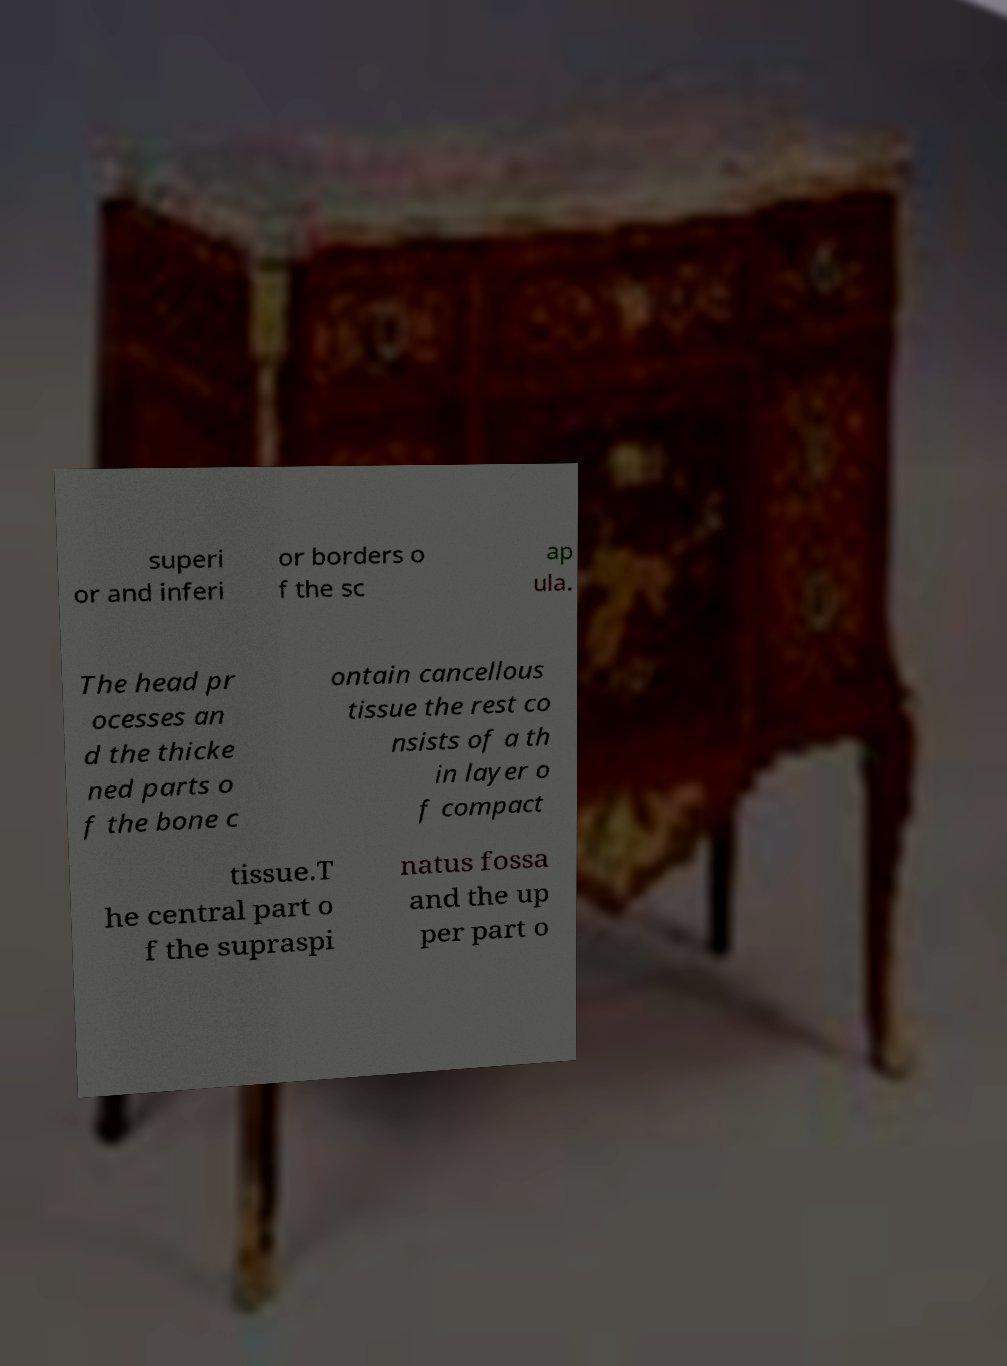Could you assist in decoding the text presented in this image and type it out clearly? superi or and inferi or borders o f the sc ap ula. The head pr ocesses an d the thicke ned parts o f the bone c ontain cancellous tissue the rest co nsists of a th in layer o f compact tissue.T he central part o f the supraspi natus fossa and the up per part o 